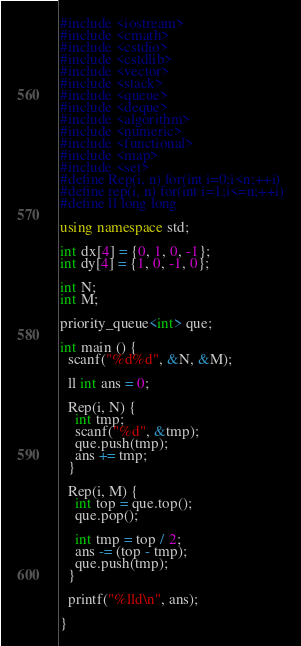<code> <loc_0><loc_0><loc_500><loc_500><_C++_>#include <iostream>
#include <cmath>
#include <cstdio>
#include <cstdlib>
#include <vector>
#include <stack>
#include <queue>
#include <deque>
#include <algorithm>
#include <numeric>
#include <functional>
#include <map>
#include <set>
#define Rep(i, n) for(int i=0;i<n;++i)
#define rep(i, n) for(int i=1;i<=n;++i)
#define ll long long

using namespace std;
 
int dx[4] = {0, 1, 0, -1};
int dy[4] = {1, 0, -1, 0};

int N;
int M;

priority_queue<int> que;

int main () {
  scanf("%d%d", &N, &M);

  ll int ans = 0;

  Rep(i, N) {
    int tmp;
    scanf("%d", &tmp);
    que.push(tmp);
    ans += tmp;
  }

  Rep(i, M) {
    int top = que.top(); 
    que.pop();

    int tmp = top / 2;
    ans -= (top - tmp);
    que.push(tmp);
  }

  printf("%lld\n", ans);
  
}</code> 